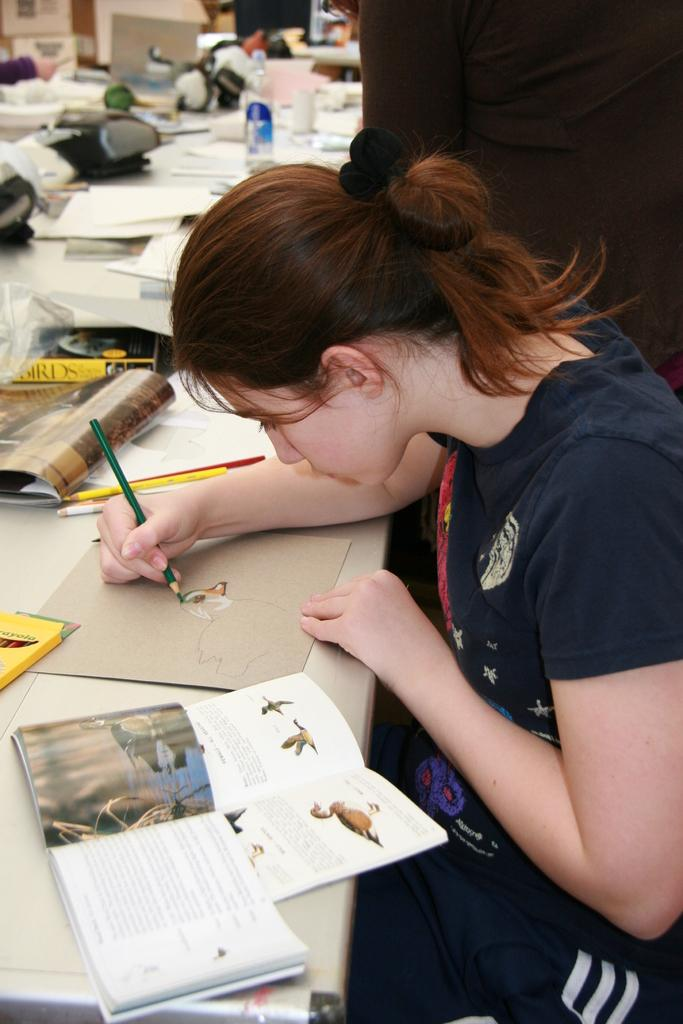What is the person in the image doing? The person is sitting and drawing in the image. What color is the person's shirt? The person is wearing a blue shirt. What color are the person's pants? The person is wearing black pants. What is on the table in the image? There are papers and bottles on the table in the image. What type of jam is the person eating while drawing in the image? There is no jam present in the image; the person is sitting and drawing. What type of laborer is depicted in the image? There is no laborer depicted in the image; the main subject is a person sitting and drawing. 